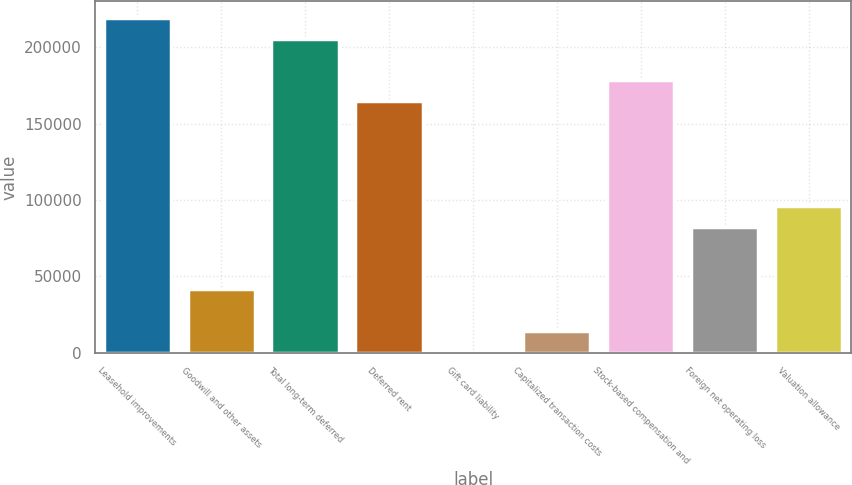<chart> <loc_0><loc_0><loc_500><loc_500><bar_chart><fcel>Leasehold improvements<fcel>Goodwill and other assets<fcel>Total long-term deferred<fcel>Deferred rent<fcel>Gift card liability<fcel>Capitalized transaction costs<fcel>Stock-based compensation and<fcel>Foreign net operating loss<fcel>Valuation allowance<nl><fcel>219242<fcel>41497.8<fcel>205569<fcel>164551<fcel>480<fcel>14152.6<fcel>178224<fcel>82515.6<fcel>96188.2<nl></chart> 